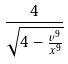Convert formula to latex. <formula><loc_0><loc_0><loc_500><loc_500>\frac { 4 } { \sqrt { 4 - \frac { v ^ { 9 } } { x ^ { 9 } } } }</formula> 